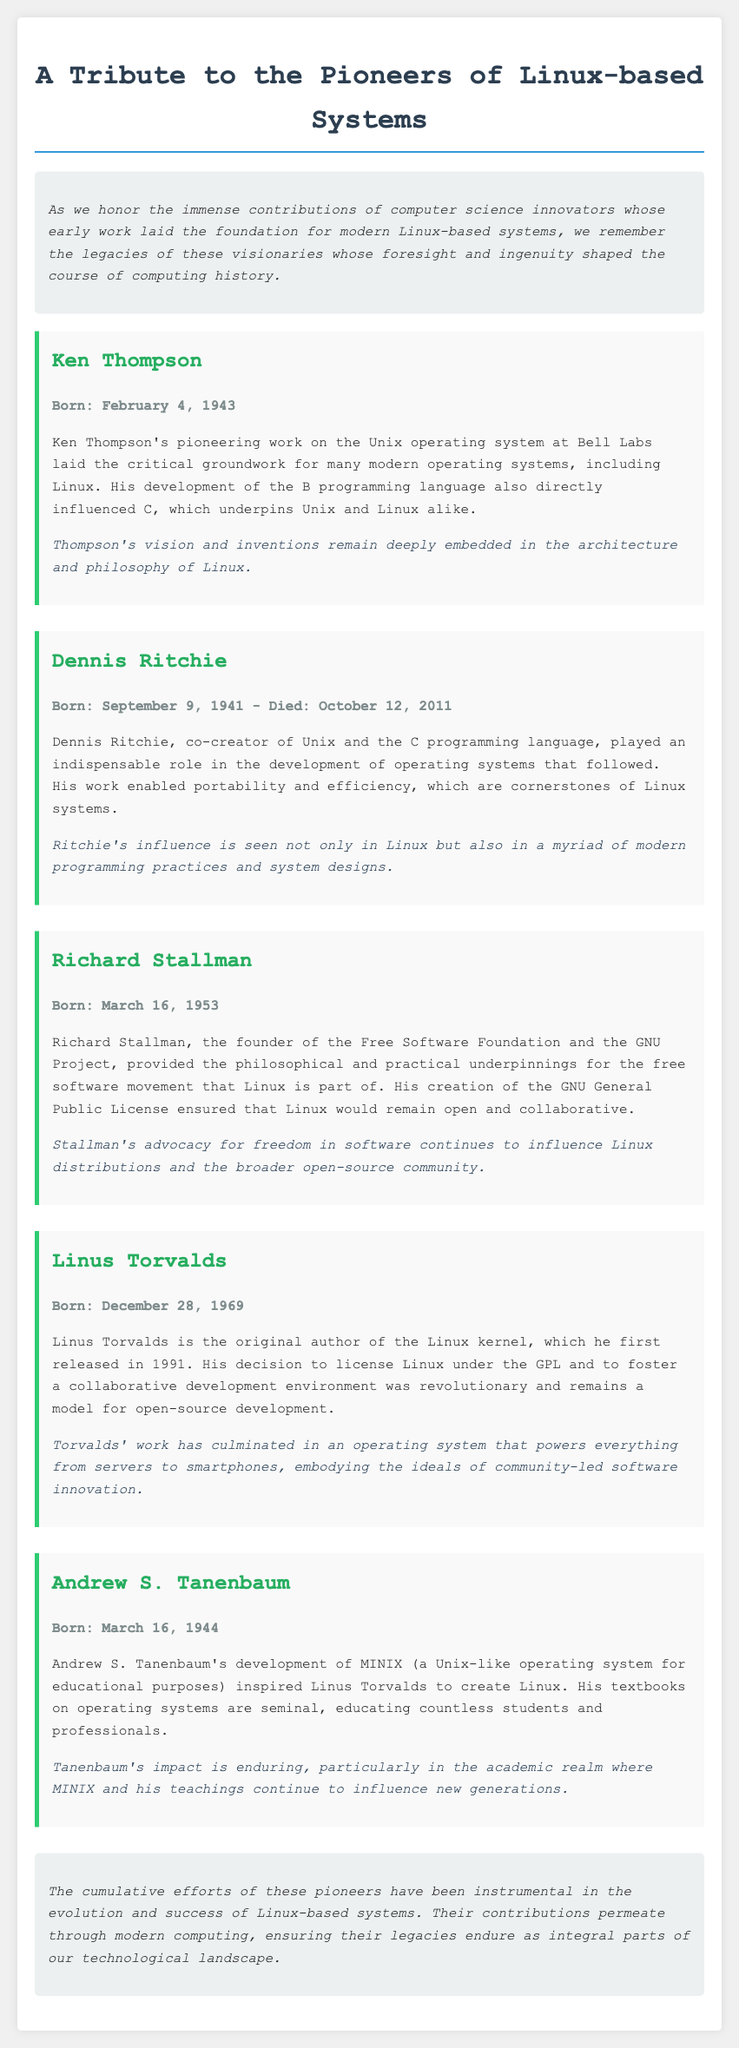What is the title of the document? The title is prominently displayed at the top of the document.
Answer: A Tribute to the Pioneers of Linux-based Systems Who was born on February 4, 1943? The document provides specific birth dates for each pioneer mentioned.
Answer: Ken Thompson When did Dennis Ritchie pass away? The document mentions the dates of birth and death for Dennis Ritchie.
Answer: October 12, 2011 What is the GNU General Public License? The document describes contributions of Richard Stallman, including his creation related to free software.
Answer: A license ensuring Linux remains open and collaborative Which operating system did Andrew S. Tanenbaum develop? The document mentions the specific operating system developed by Tanenbaum.
Answer: MINIX Why is Linus Torvalds significant? The document explains the contributions of Linus Torvalds to the Linux kernel and the licensing decision.
Answer: Original author of the Linux kernel What common theme connects the contributions of all pioneers? The document summarizes their collective impact on Linux-based systems.
Answer: Innovation in operating systems What academic impact did Andrew S. Tanenbaum have? The document references Tanenbaum's textbooks and their influence.
Answer: Educating countless students and professionals 